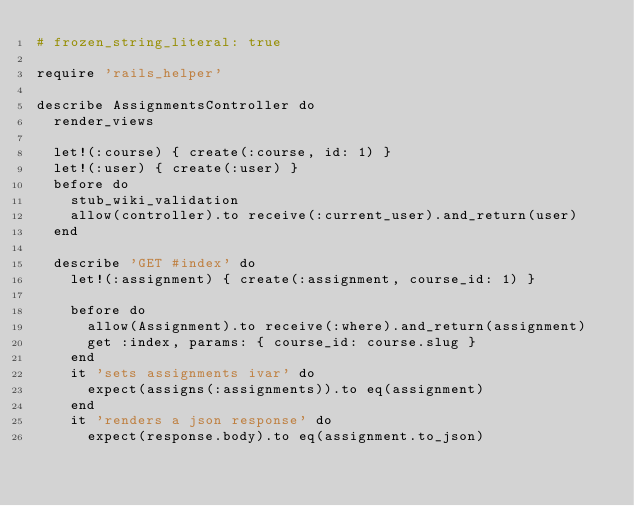<code> <loc_0><loc_0><loc_500><loc_500><_Ruby_># frozen_string_literal: true

require 'rails_helper'

describe AssignmentsController do
  render_views

  let!(:course) { create(:course, id: 1) }
  let!(:user) { create(:user) }
  before do
    stub_wiki_validation
    allow(controller).to receive(:current_user).and_return(user)
  end

  describe 'GET #index' do
    let!(:assignment) { create(:assignment, course_id: 1) }

    before do
      allow(Assignment).to receive(:where).and_return(assignment)
      get :index, params: { course_id: course.slug }
    end
    it 'sets assignments ivar' do
      expect(assigns(:assignments)).to eq(assignment)
    end
    it 'renders a json response' do
      expect(response.body).to eq(assignment.to_json)</code> 